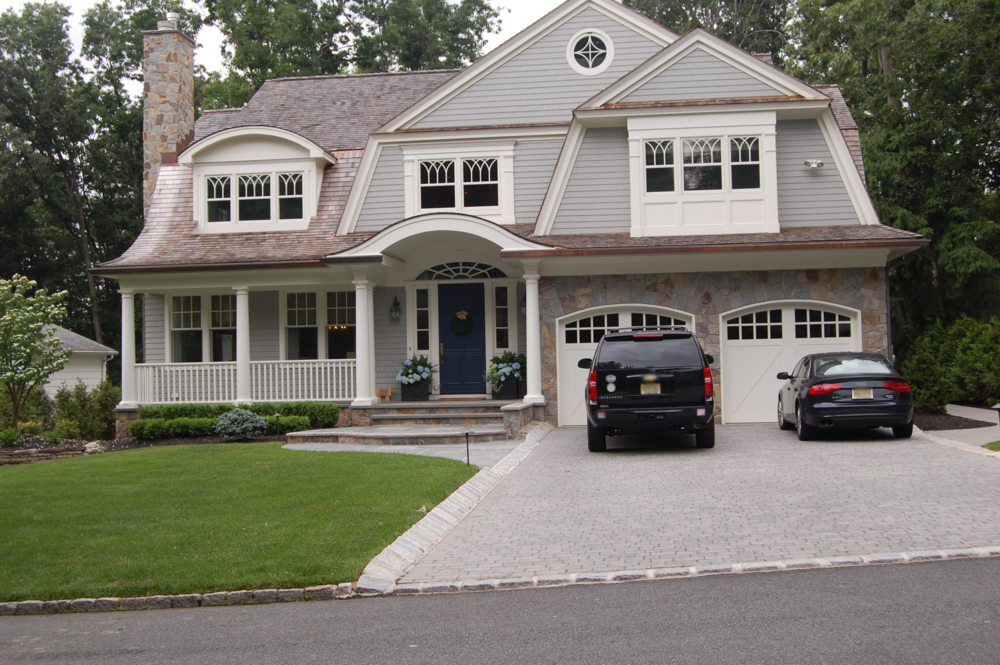Describe the color palette and texture of the house. How do these elements enhance its overall appeal? The house features a soothing and elegant color palette that combines soft grays with crisp white accents. The textured stonework around the garage and chimney introduces a rustic charm, while the smooth wooden siding enhances the Craftsman appeal. The dark blue door acts as a focal point, adding a pop of color that draws the eye. These elements work together harmoniously, creating a welcoming and cohesive appearance that blends traditional craftsmanship with modern sensibilities. 